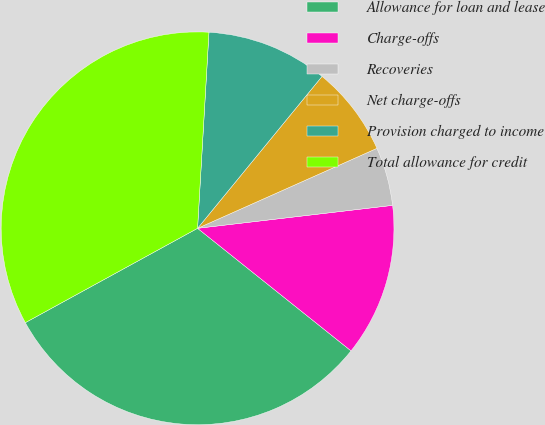<chart> <loc_0><loc_0><loc_500><loc_500><pie_chart><fcel>Allowance for loan and lease<fcel>Charge-offs<fcel>Recoveries<fcel>Net charge-offs<fcel>Provision charged to income<fcel>Total allowance for credit<nl><fcel>31.3%<fcel>12.59%<fcel>4.81%<fcel>7.4%<fcel>10.0%<fcel>33.9%<nl></chart> 